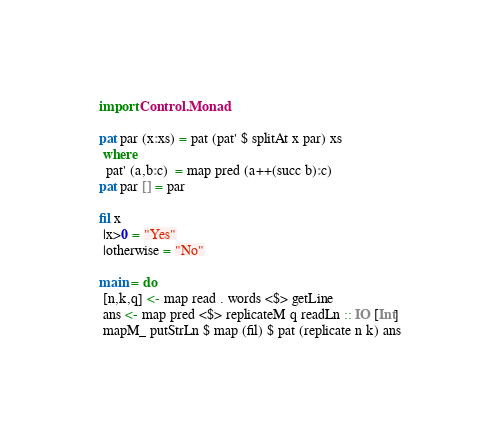Convert code to text. <code><loc_0><loc_0><loc_500><loc_500><_Haskell_>import Control.Monad
  
pat par (x:xs) = pat (pat' $ splitAt x par) xs
 where
  pat' (a,b:c)  = map pred (a++(succ b):c)
pat par [] = par

fil x
 |x>0 = "Yes"
 |otherwise = "No"

main = do
 [n,k,q] <- map read . words <$> getLine
 ans <- map pred <$> replicateM q readLn :: IO [Int]
 mapM_ putStrLn $ map (fil) $ pat (replicate n k) ans</code> 